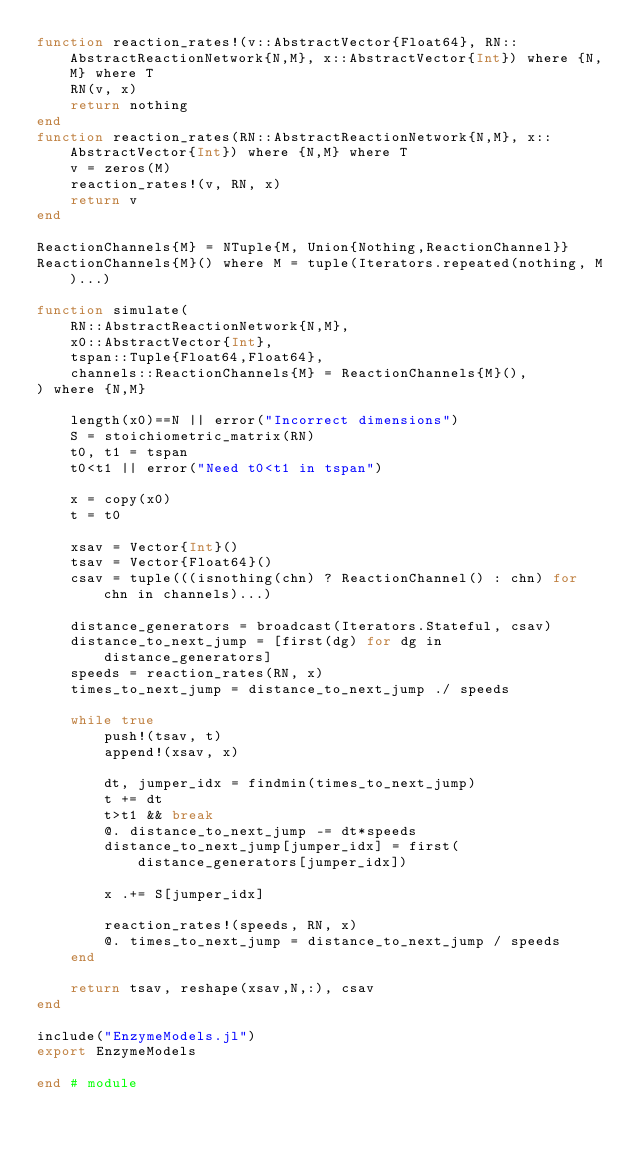Convert code to text. <code><loc_0><loc_0><loc_500><loc_500><_Julia_>function reaction_rates!(v::AbstractVector{Float64}, RN::AbstractReactionNetwork{N,M}, x::AbstractVector{Int}) where {N,M} where T
    RN(v, x)
    return nothing
end
function reaction_rates(RN::AbstractReactionNetwork{N,M}, x::AbstractVector{Int}) where {N,M} where T
    v = zeros(M)
    reaction_rates!(v, RN, x)
    return v
end

ReactionChannels{M} = NTuple{M, Union{Nothing,ReactionChannel}}
ReactionChannels{M}() where M = tuple(Iterators.repeated(nothing, M)...)

function simulate(
    RN::AbstractReactionNetwork{N,M},
    x0::AbstractVector{Int},
    tspan::Tuple{Float64,Float64},
    channels::ReactionChannels{M} = ReactionChannels{M}(),
) where {N,M}
    
    length(x0)==N || error("Incorrect dimensions")
    S = stoichiometric_matrix(RN)
    t0, t1 = tspan
    t0<t1 || error("Need t0<t1 in tspan")

    x = copy(x0)
    t = t0

    xsav = Vector{Int}()
    tsav = Vector{Float64}()
    csav = tuple(((isnothing(chn) ? ReactionChannel() : chn) for chn in channels)...)

    distance_generators = broadcast(Iterators.Stateful, csav)
    distance_to_next_jump = [first(dg) for dg in distance_generators]
    speeds = reaction_rates(RN, x)
    times_to_next_jump = distance_to_next_jump ./ speeds
        
    while true
        push!(tsav, t)
        append!(xsav, x)
        
        dt, jumper_idx = findmin(times_to_next_jump)
        t += dt
        t>t1 && break
        @. distance_to_next_jump -= dt*speeds
        distance_to_next_jump[jumper_idx] = first(distance_generators[jumper_idx])

        x .+= S[jumper_idx]
        
        reaction_rates!(speeds, RN, x)
        @. times_to_next_jump = distance_to_next_jump / speeds
    end
    
    return tsav, reshape(xsav,N,:), csav
end

include("EnzymeModels.jl")
export EnzymeModels

end # module
</code> 